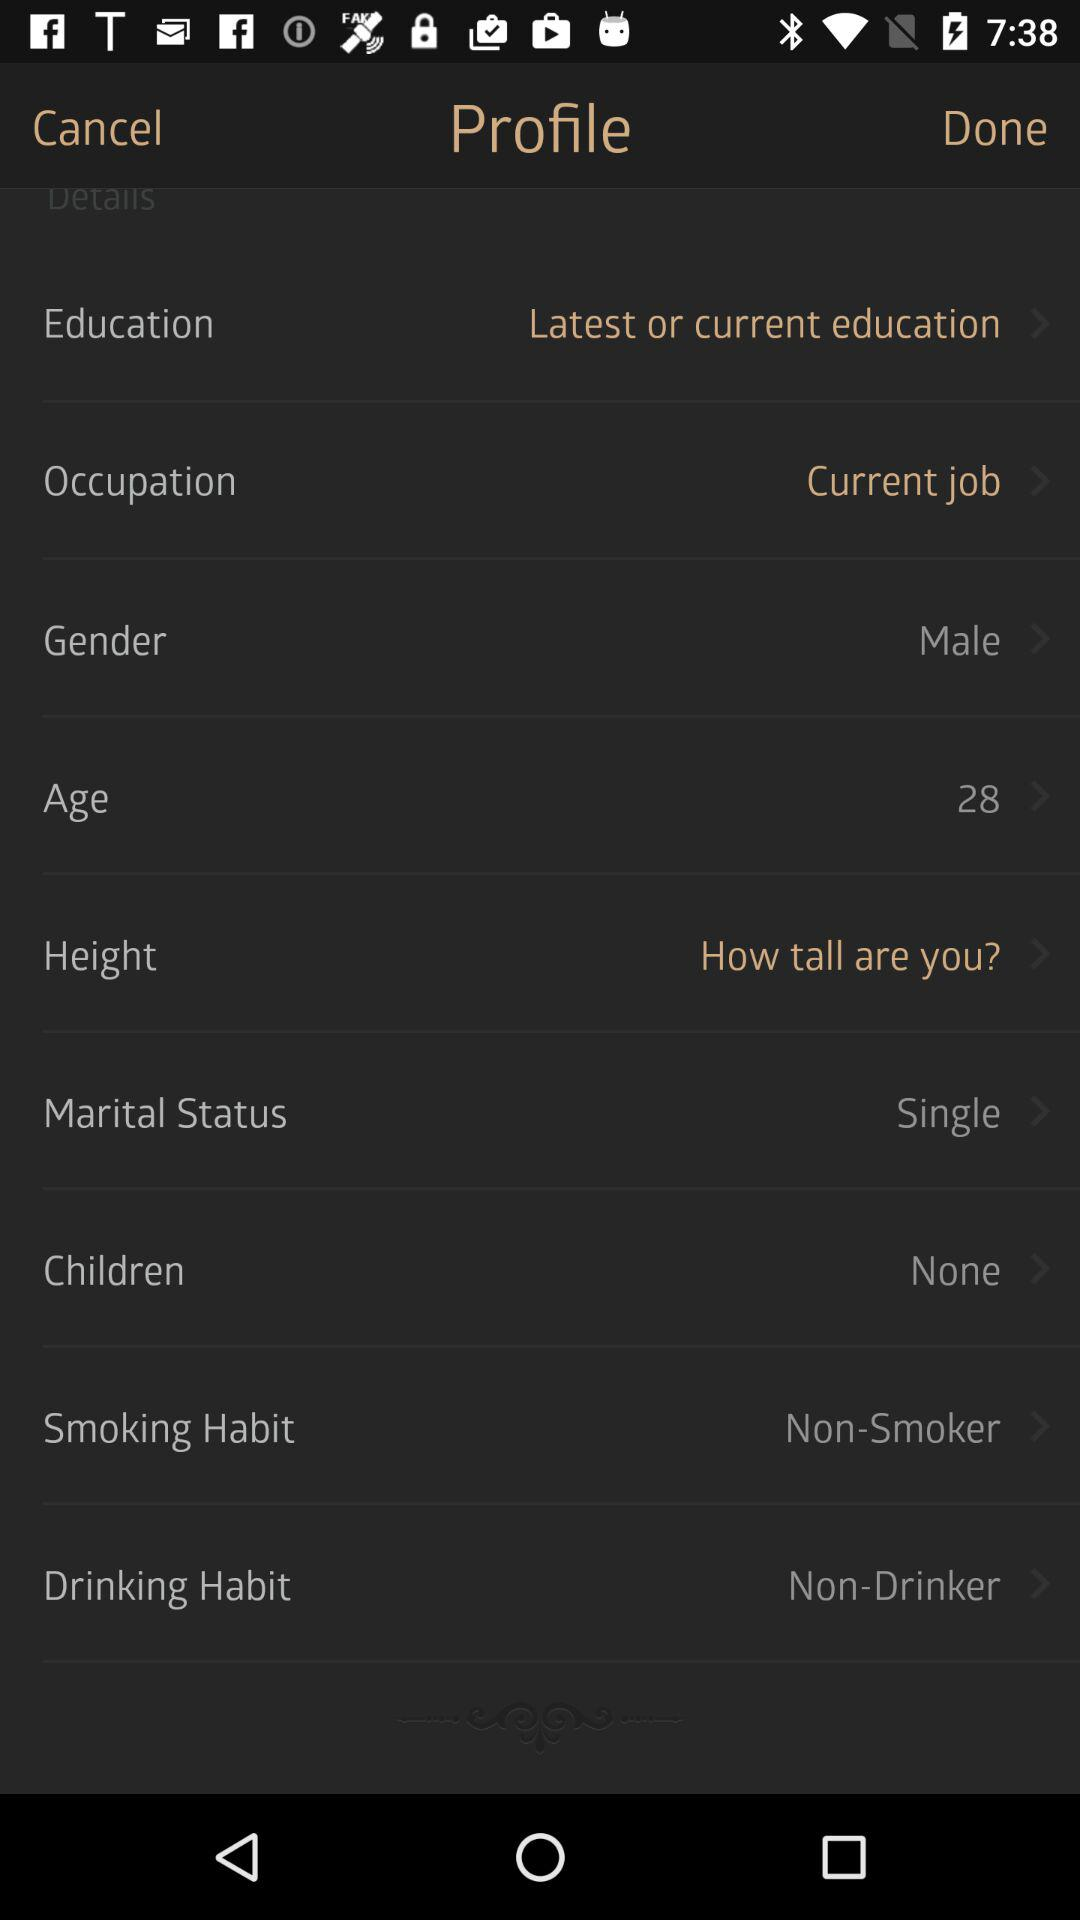What is the smoking habit? The smoking habit is "Non-Smoker". 